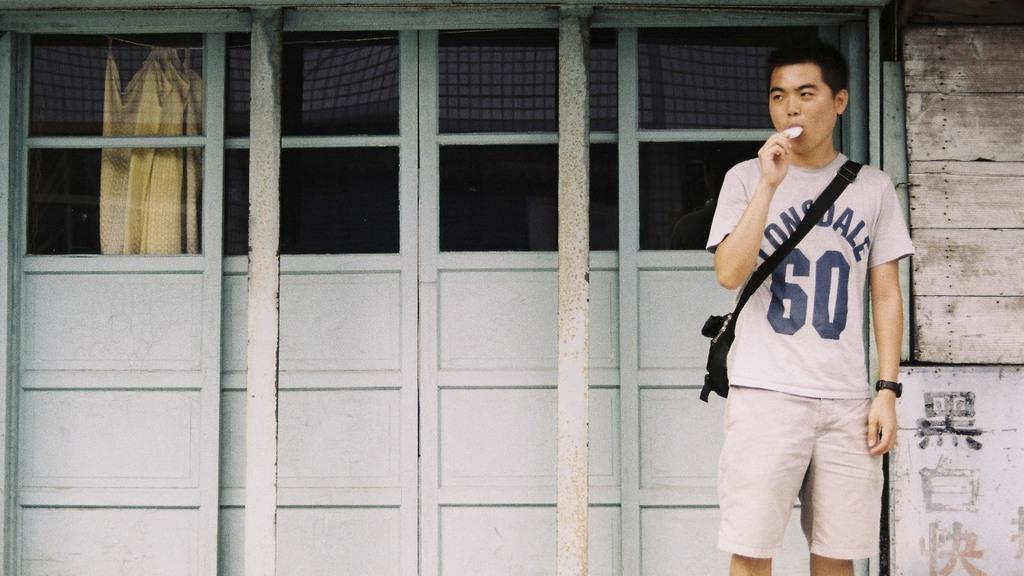Provide a one-sentence caption for the provided image. A boy  standing in front of a door with a t shirt  that has the number 60 on top. 